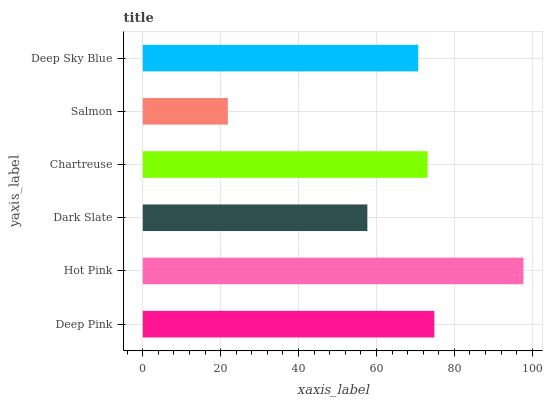Is Salmon the minimum?
Answer yes or no. Yes. Is Hot Pink the maximum?
Answer yes or no. Yes. Is Dark Slate the minimum?
Answer yes or no. No. Is Dark Slate the maximum?
Answer yes or no. No. Is Hot Pink greater than Dark Slate?
Answer yes or no. Yes. Is Dark Slate less than Hot Pink?
Answer yes or no. Yes. Is Dark Slate greater than Hot Pink?
Answer yes or no. No. Is Hot Pink less than Dark Slate?
Answer yes or no. No. Is Chartreuse the high median?
Answer yes or no. Yes. Is Deep Sky Blue the low median?
Answer yes or no. Yes. Is Deep Pink the high median?
Answer yes or no. No. Is Hot Pink the low median?
Answer yes or no. No. 